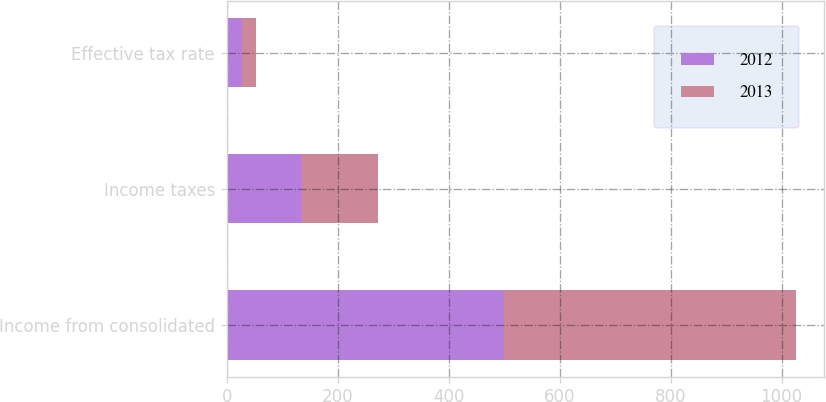Convert chart to OTSL. <chart><loc_0><loc_0><loc_500><loc_500><stacked_bar_chart><ecel><fcel>Income from consolidated<fcel>Income taxes<fcel>Effective tax rate<nl><fcel>2012<fcel>499.4<fcel>133.6<fcel>26.8<nl><fcel>2013<fcel>526.1<fcel>139.8<fcel>26.6<nl></chart> 